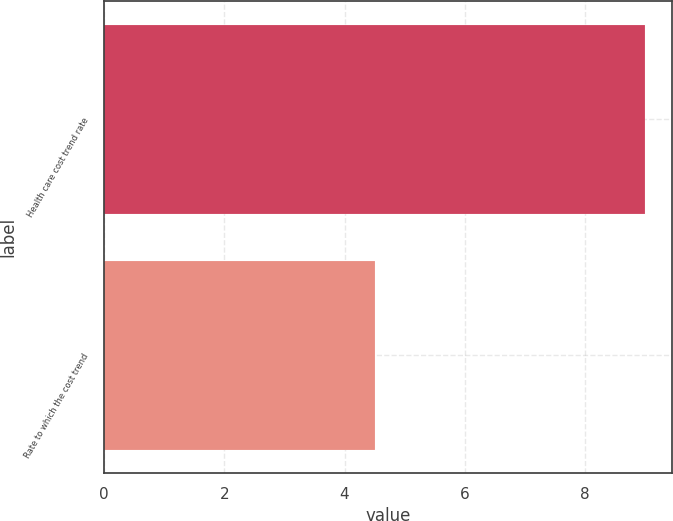Convert chart to OTSL. <chart><loc_0><loc_0><loc_500><loc_500><bar_chart><fcel>Health care cost trend rate<fcel>Rate to which the cost trend<nl><fcel>9<fcel>4.5<nl></chart> 